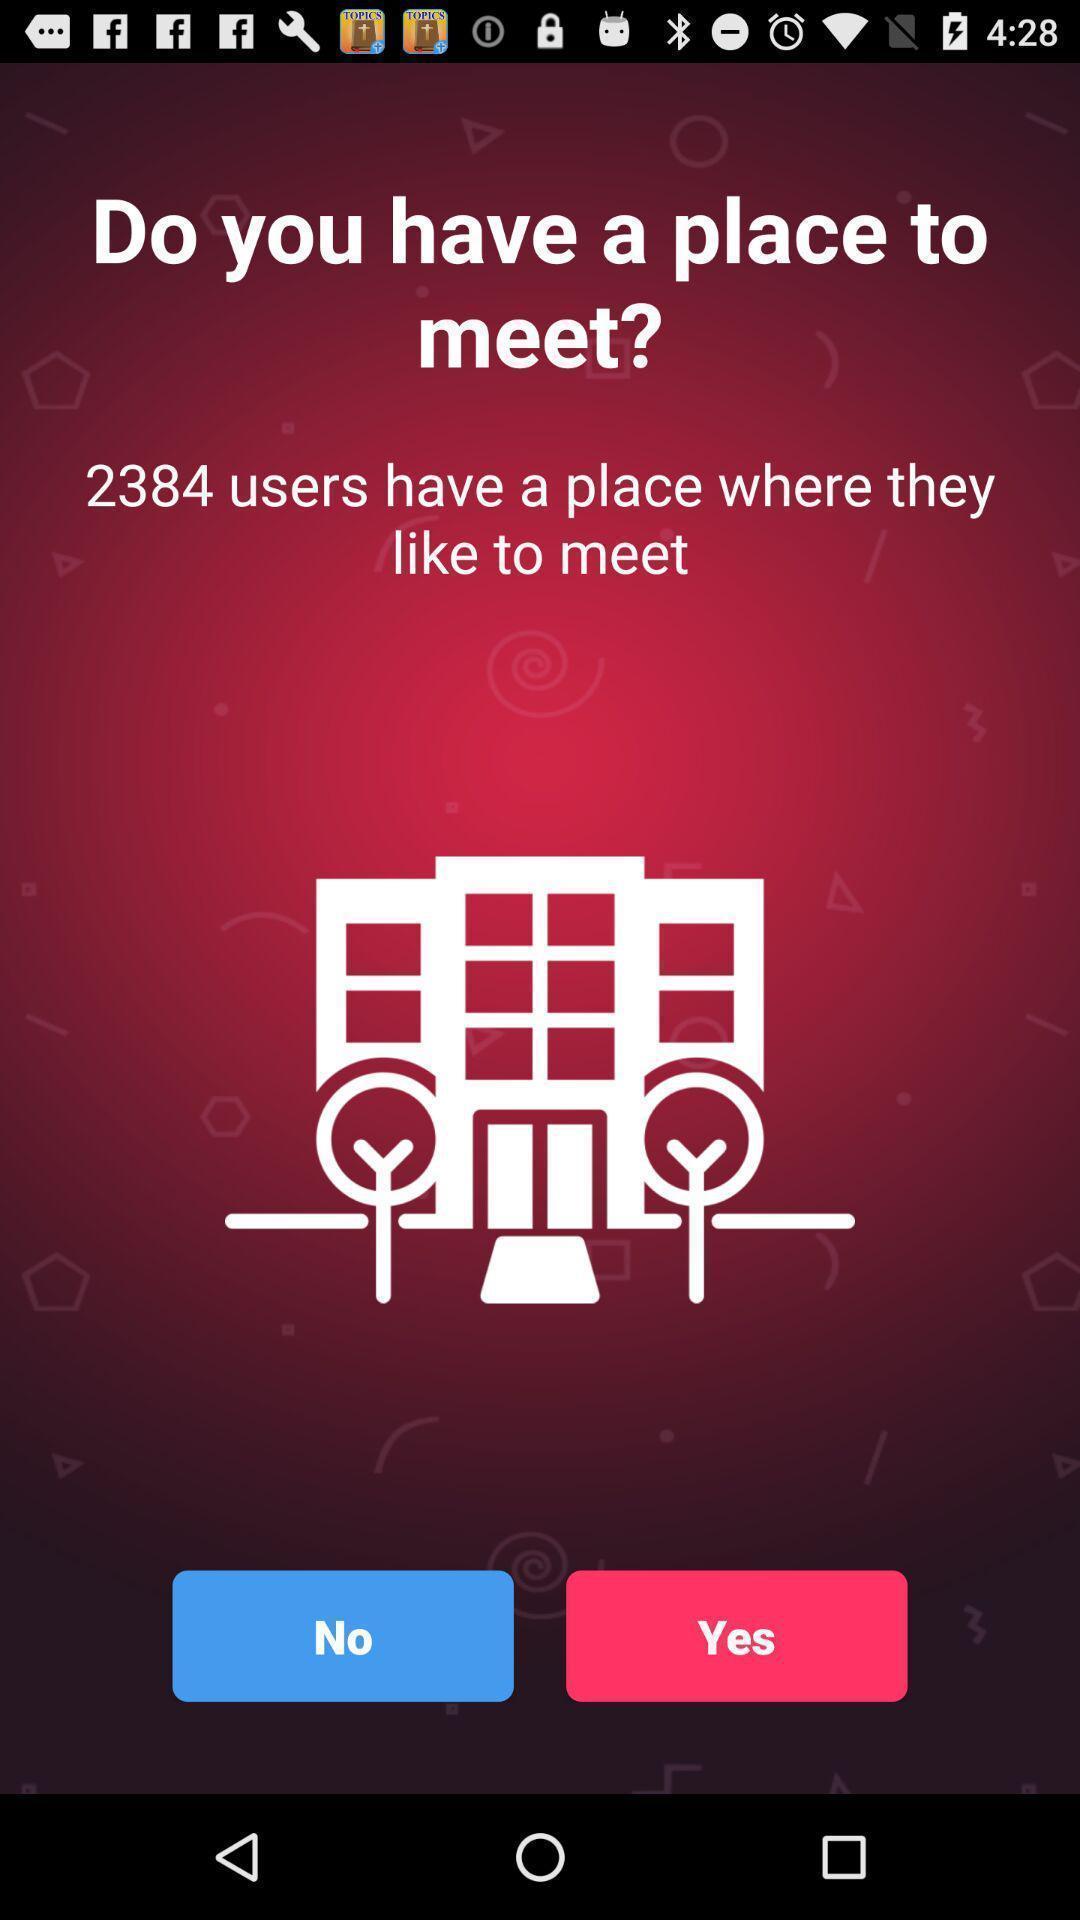Tell me what you see in this picture. Screen displaying information about a dating application. 